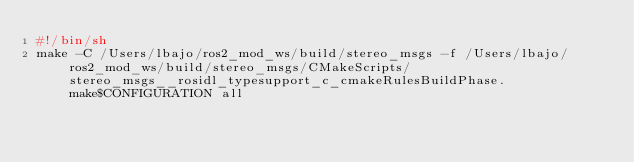<code> <loc_0><loc_0><loc_500><loc_500><_Bash_>#!/bin/sh
make -C /Users/lbajo/ros2_mod_ws/build/stereo_msgs -f /Users/lbajo/ros2_mod_ws/build/stereo_msgs/CMakeScripts/stereo_msgs__rosidl_typesupport_c_cmakeRulesBuildPhase.make$CONFIGURATION all
</code> 